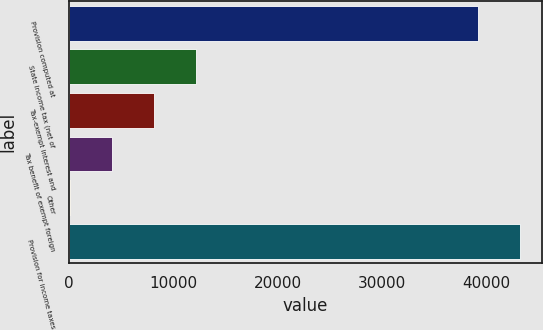Convert chart. <chart><loc_0><loc_0><loc_500><loc_500><bar_chart><fcel>Provision computed at<fcel>State income tax (net of<fcel>Tax-exempt interest and<fcel>Tax benefit of exempt foreign<fcel>Other<fcel>Provision for income taxes<nl><fcel>39169<fcel>12182.6<fcel>8167.4<fcel>4152.2<fcel>137<fcel>43184.2<nl></chart> 